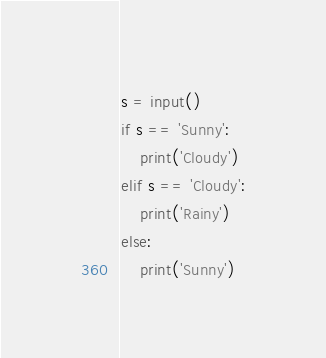<code> <loc_0><loc_0><loc_500><loc_500><_Python_>s = input()
if s == 'Sunny':
    print('Cloudy')
elif s == 'Cloudy':
    print('Rainy')
else:
    print('Sunny')</code> 